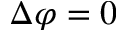Convert formula to latex. <formula><loc_0><loc_0><loc_500><loc_500>\Delta \varphi = 0</formula> 